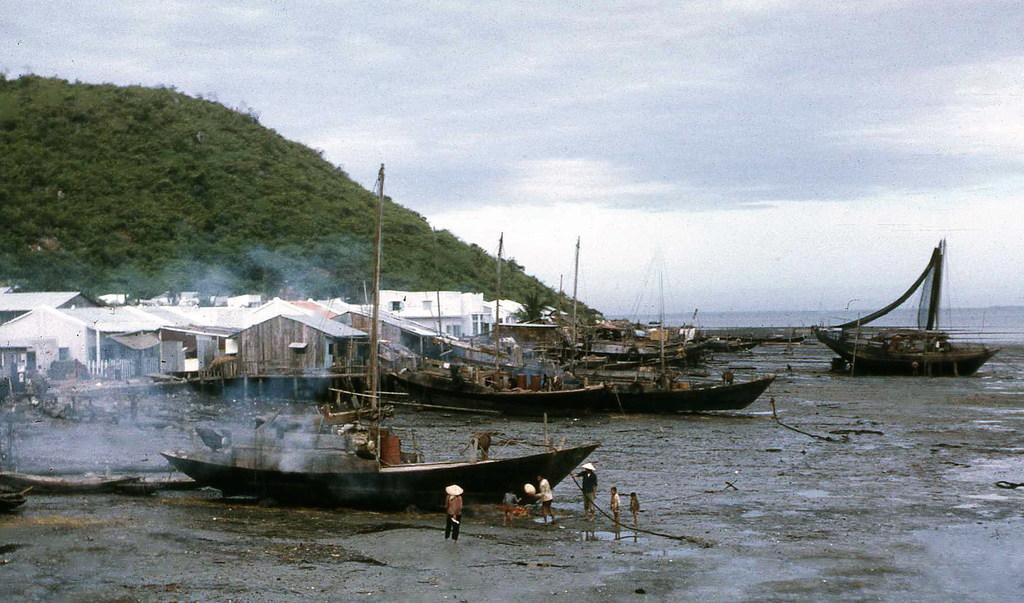Could you give a brief overview of what you see in this image? In the image we can see there are boats and there are people standing, wearing clothes and a hat. Here we can see mud, smoke and there are few houses. Here we can see hill, water and a cloudy sky. 